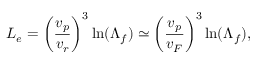<formula> <loc_0><loc_0><loc_500><loc_500>L _ { e } = \left ( \frac { v _ { p } } { v _ { r } } \right ) ^ { 3 } \ln ( \Lambda _ { f } ) \simeq \left ( \frac { v _ { p } } { v _ { F } } \right ) ^ { 3 } \ln ( \Lambda _ { f } ) ,</formula> 